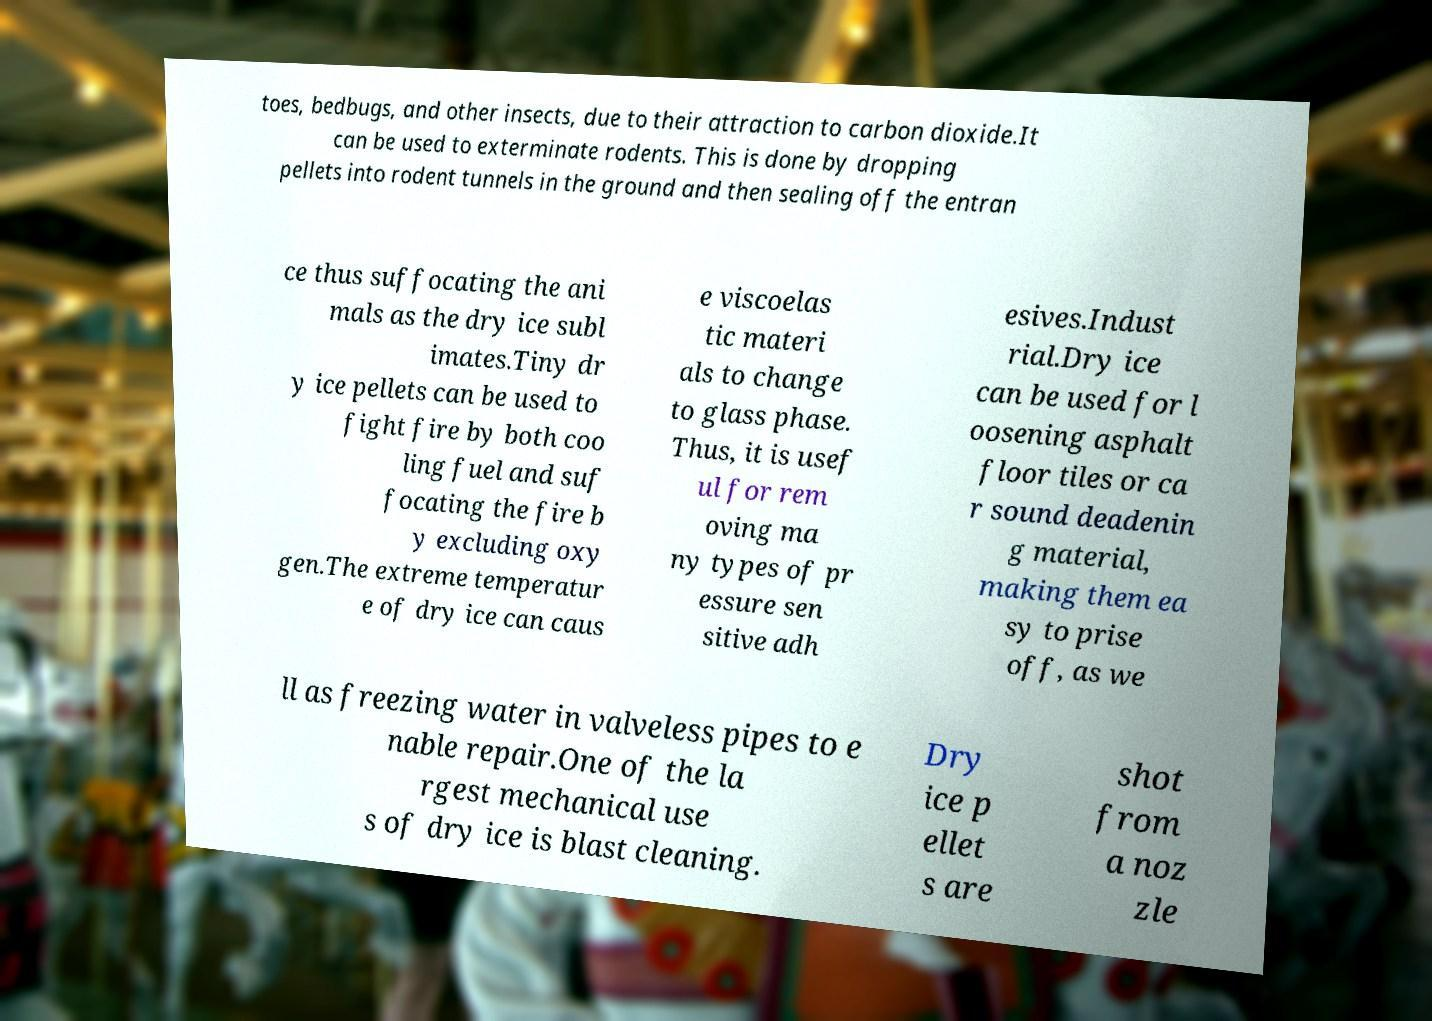Could you assist in decoding the text presented in this image and type it out clearly? toes, bedbugs, and other insects, due to their attraction to carbon dioxide.It can be used to exterminate rodents. This is done by dropping pellets into rodent tunnels in the ground and then sealing off the entran ce thus suffocating the ani mals as the dry ice subl imates.Tiny dr y ice pellets can be used to fight fire by both coo ling fuel and suf focating the fire b y excluding oxy gen.The extreme temperatur e of dry ice can caus e viscoelas tic materi als to change to glass phase. Thus, it is usef ul for rem oving ma ny types of pr essure sen sitive adh esives.Indust rial.Dry ice can be used for l oosening asphalt floor tiles or ca r sound deadenin g material, making them ea sy to prise off, as we ll as freezing water in valveless pipes to e nable repair.One of the la rgest mechanical use s of dry ice is blast cleaning. Dry ice p ellet s are shot from a noz zle 